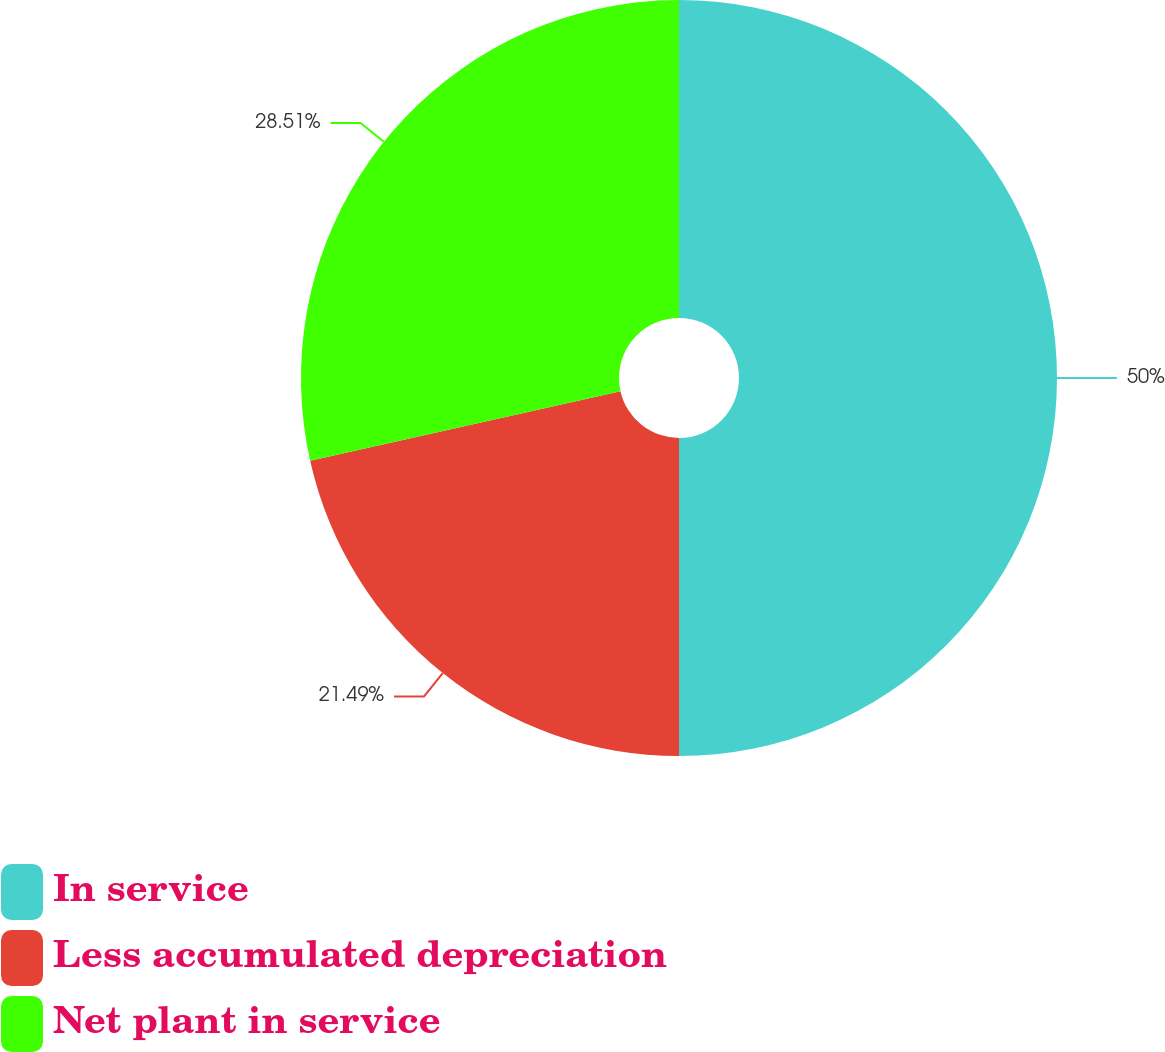Convert chart. <chart><loc_0><loc_0><loc_500><loc_500><pie_chart><fcel>In service<fcel>Less accumulated depreciation<fcel>Net plant in service<nl><fcel>50.0%<fcel>21.49%<fcel>28.51%<nl></chart> 